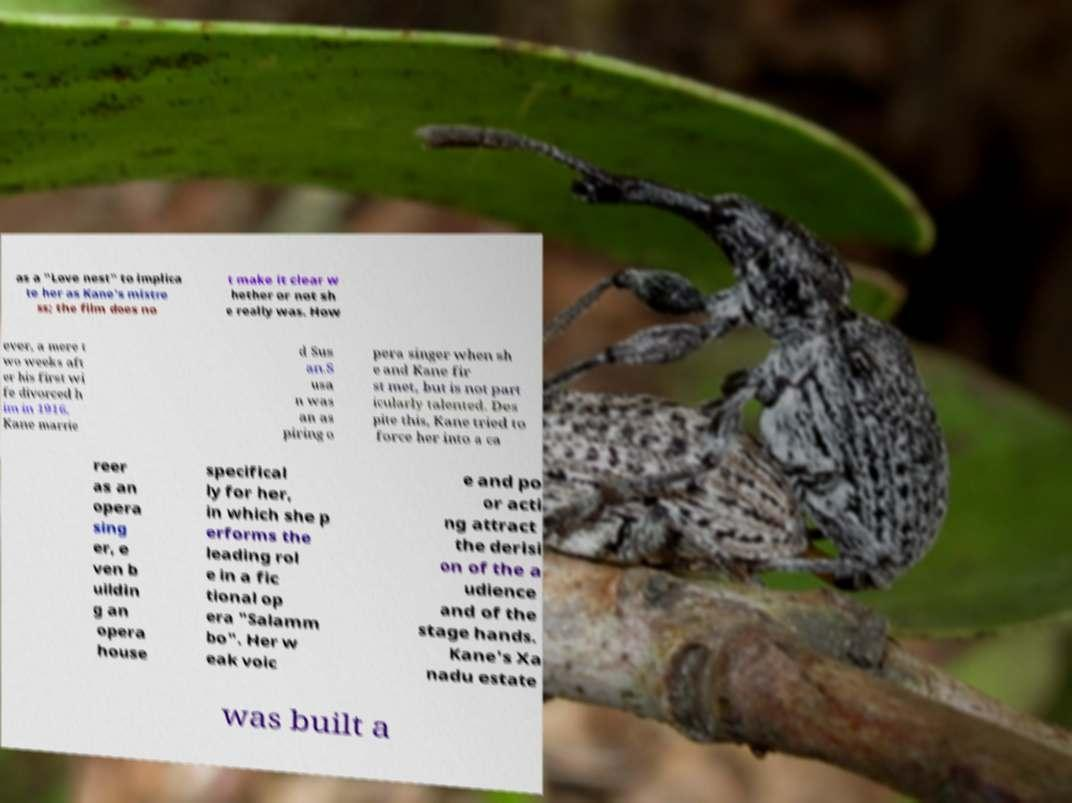Please identify and transcribe the text found in this image. as a "Love nest" to implica te her as Kane's mistre ss; the film does no t make it clear w hether or not sh e really was. How ever, a mere t wo weeks aft er his first wi fe divorced h im in 1916, Kane marrie d Sus an.S usa n was an as piring o pera singer when sh e and Kane fir st met, but is not part icularly talented. Des pite this, Kane tried to force her into a ca reer as an opera sing er, e ven b uildin g an opera house specifical ly for her, in which she p erforms the leading rol e in a fic tional op era "Salamm bo". Her w eak voic e and po or acti ng attract the derisi on of the a udience and of the stage hands. Kane's Xa nadu estate was built a 